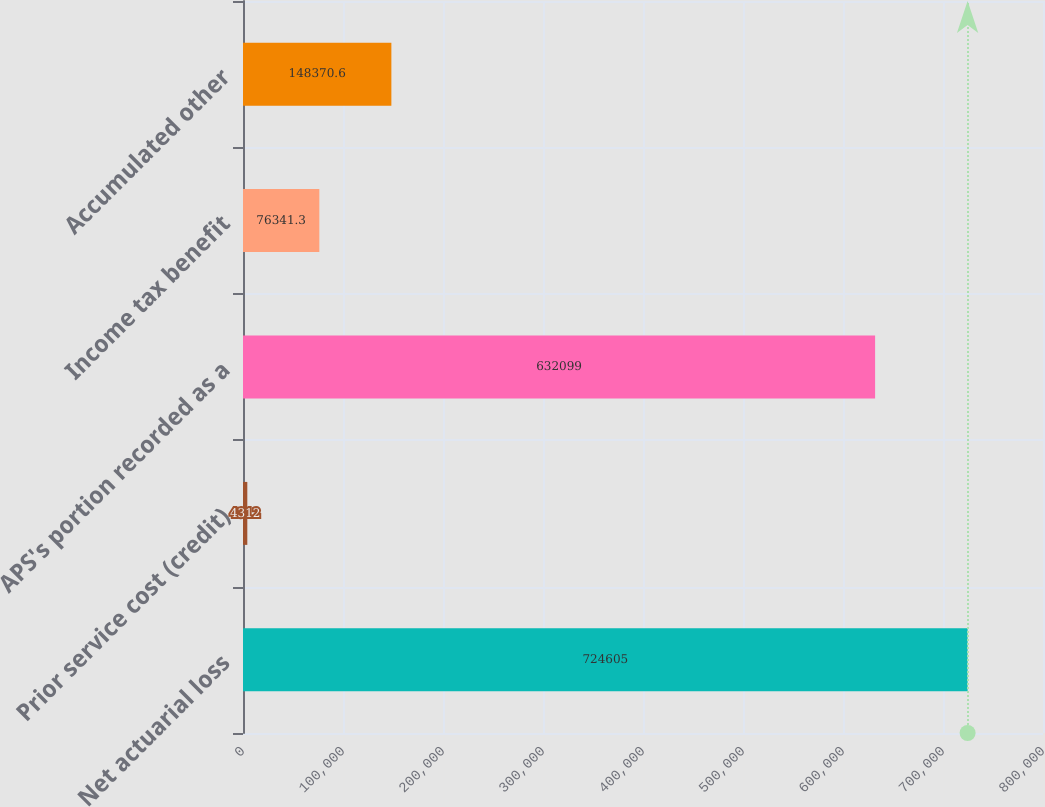<chart> <loc_0><loc_0><loc_500><loc_500><bar_chart><fcel>Net actuarial loss<fcel>Prior service cost (credit)<fcel>APS's portion recorded as a<fcel>Income tax benefit<fcel>Accumulated other<nl><fcel>724605<fcel>4312<fcel>632099<fcel>76341.3<fcel>148371<nl></chart> 